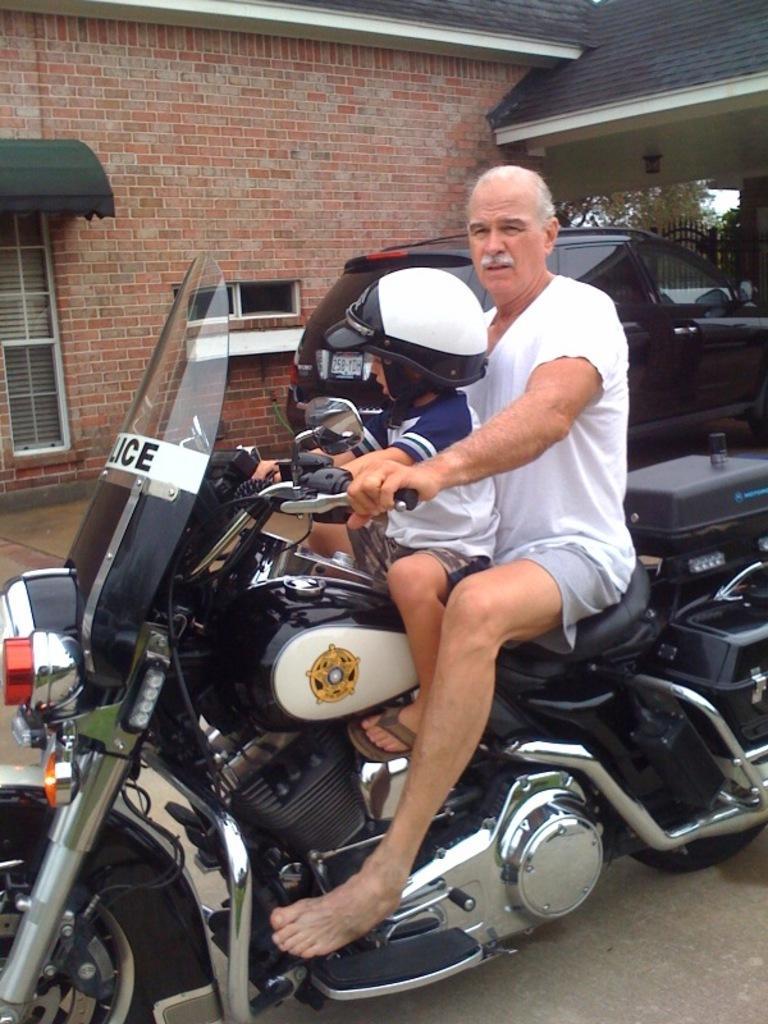In one or two sentences, can you explain what this image depicts? In this picture we have a old man and a boy riding the bike. The boy is wearing a helmet. In the background there is a brick wall and car. 